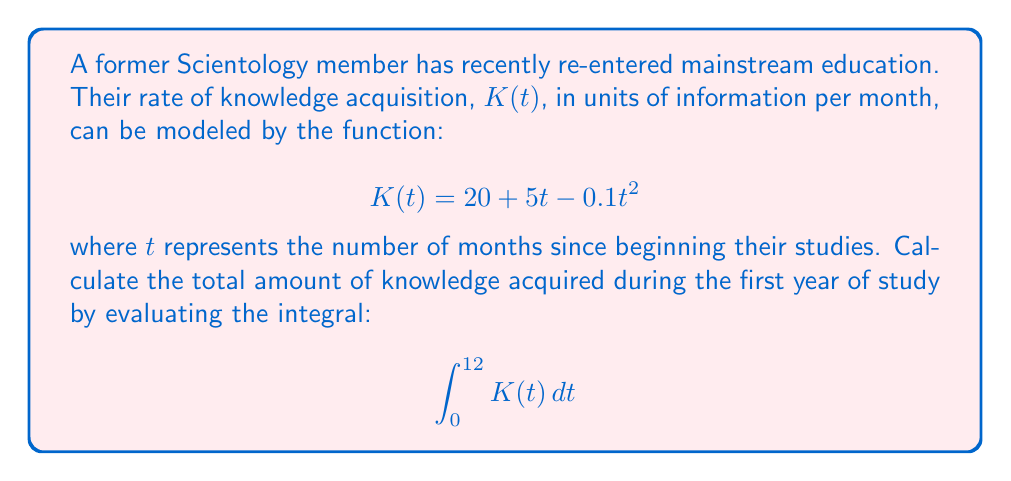What is the answer to this math problem? To solve this problem, we need to integrate the given function $K(t)$ over the interval $[0, 12]$. Let's break it down step-by-step:

1) First, let's set up the integral:
   $$\int_0^{12} (20 + 5t - 0.1t^2) dt$$

2) Now, we integrate each term separately:

   a) $\int 20 dt = 20t$
   b) $\int 5t dt = \frac{5t^2}{2}$
   c) $\int -0.1t^2 dt = -\frac{0.1t^3}{3}$

3) Combining these, we get:
   $$\left[20t + \frac{5t^2}{2} - \frac{0.1t^3}{3}\right]_0^{12}$$

4) Now, we evaluate this expression at the upper and lower bounds:

   At t = 12:
   $$20(12) + \frac{5(12^2)}{2} - \frac{0.1(12^3)}{3} = 240 + 360 - 57.6 = 542.4$$

   At t = 0:
   $$20(0) + \frac{5(0^2)}{2} - \frac{0.1(0^3)}{3} = 0$$

5) The final result is the difference between these values:
   $$542.4 - 0 = 542.4$$

Therefore, the total amount of knowledge acquired during the first year is 542.4 units of information.
Answer: 542.4 units of information 